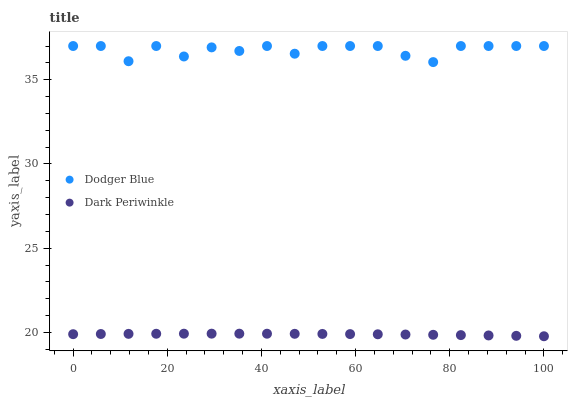Does Dark Periwinkle have the minimum area under the curve?
Answer yes or no. Yes. Does Dodger Blue have the maximum area under the curve?
Answer yes or no. Yes. Does Dark Periwinkle have the maximum area under the curve?
Answer yes or no. No. Is Dark Periwinkle the smoothest?
Answer yes or no. Yes. Is Dodger Blue the roughest?
Answer yes or no. Yes. Is Dark Periwinkle the roughest?
Answer yes or no. No. Does Dark Periwinkle have the lowest value?
Answer yes or no. Yes. Does Dodger Blue have the highest value?
Answer yes or no. Yes. Does Dark Periwinkle have the highest value?
Answer yes or no. No. Is Dark Periwinkle less than Dodger Blue?
Answer yes or no. Yes. Is Dodger Blue greater than Dark Periwinkle?
Answer yes or no. Yes. Does Dark Periwinkle intersect Dodger Blue?
Answer yes or no. No. 